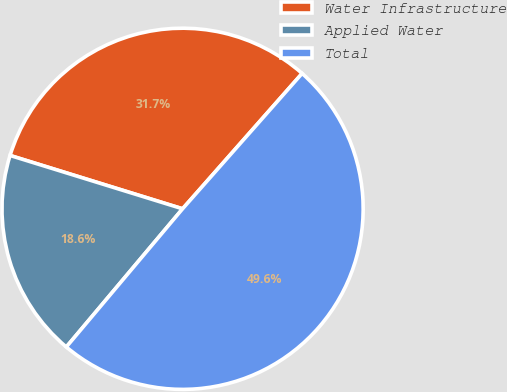Convert chart. <chart><loc_0><loc_0><loc_500><loc_500><pie_chart><fcel>Water Infrastructure<fcel>Applied Water<fcel>Total<nl><fcel>31.74%<fcel>18.64%<fcel>49.62%<nl></chart> 